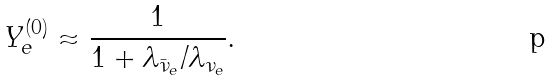<formula> <loc_0><loc_0><loc_500><loc_500>Y _ { e } ^ { ( 0 ) } \approx \frac { 1 } { 1 + \lambda _ { \bar { \nu } _ { e } } / \lambda _ { \nu _ { e } } } .</formula> 